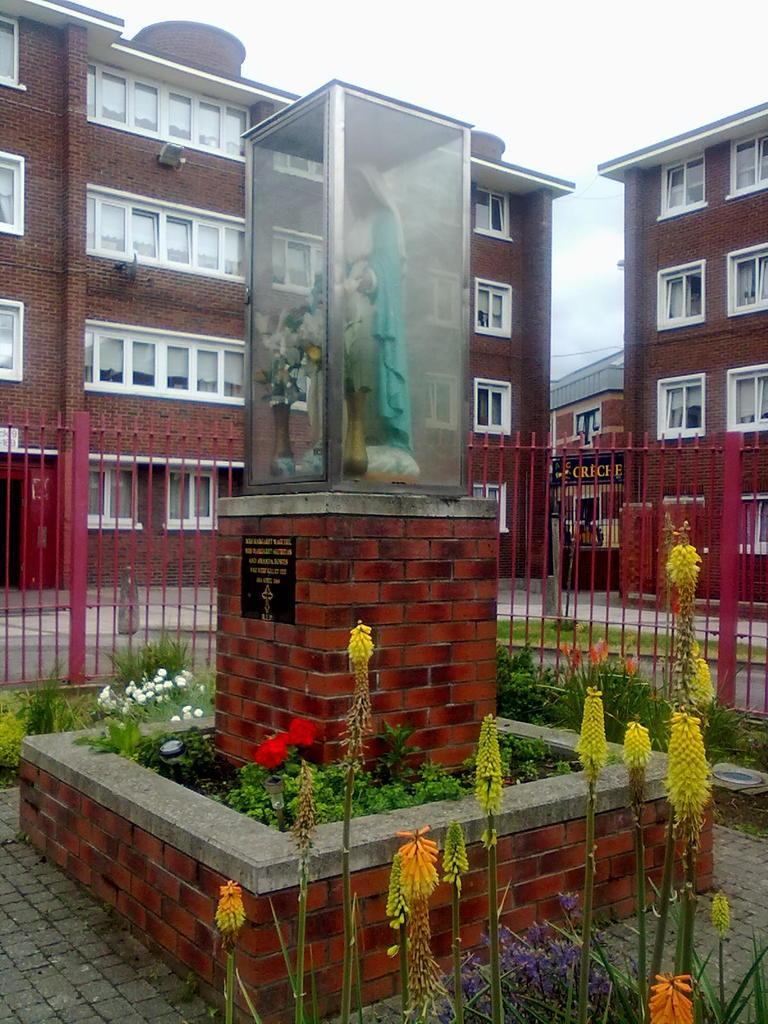How would you summarize this image in a sentence or two? These are the buildings with windows. This looks like a sculpture, which is covered with a glass box. This sculpture is placed on the pillar. This looks like a board, which is attached to the pillar. These are the plants with colorful flowers. I think these are the kind of barricades. 